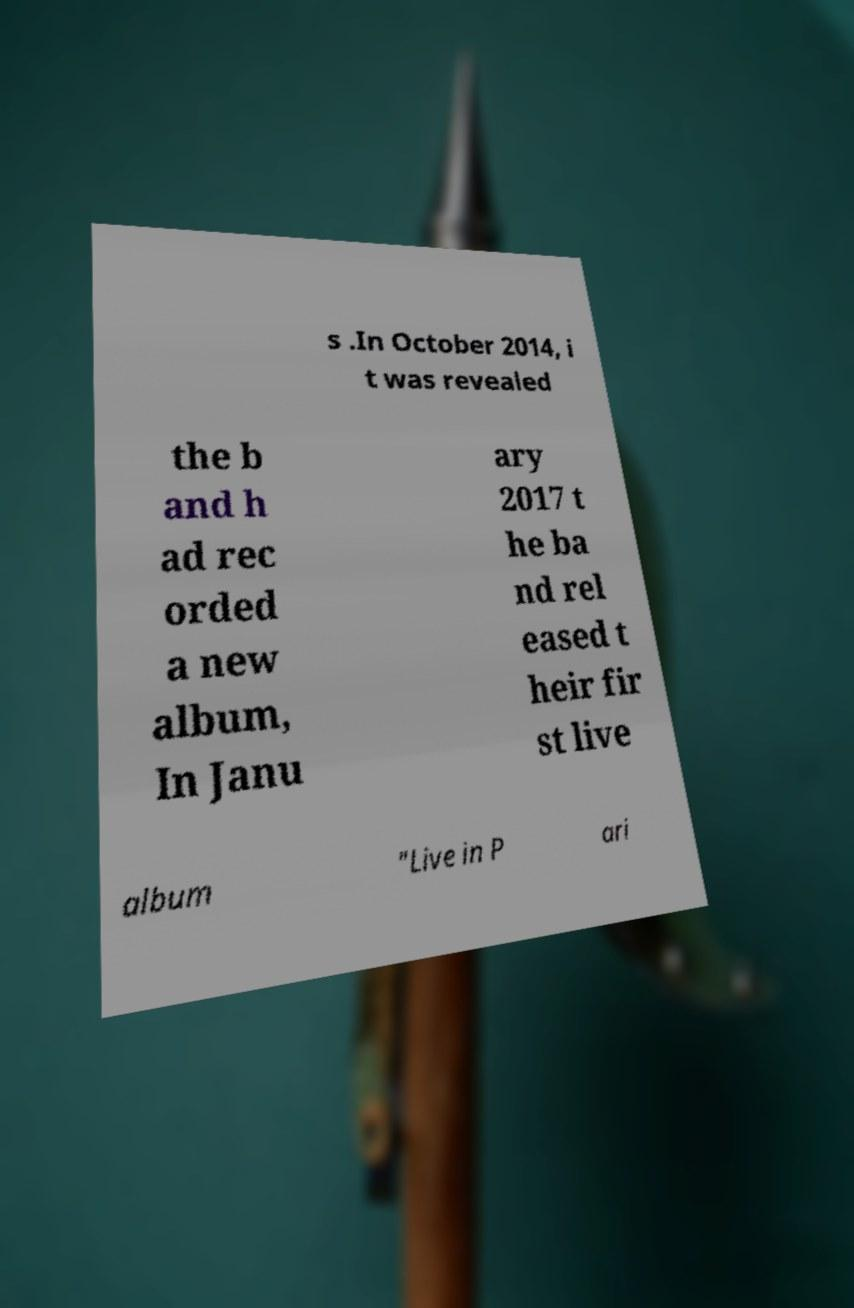Please identify and transcribe the text found in this image. s .In October 2014, i t was revealed the b and h ad rec orded a new album, In Janu ary 2017 t he ba nd rel eased t heir fir st live album "Live in P ari 